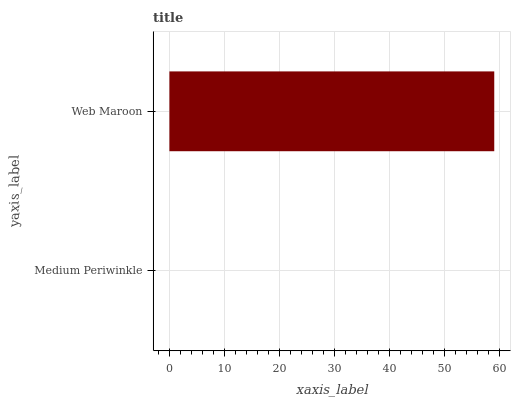Is Medium Periwinkle the minimum?
Answer yes or no. Yes. Is Web Maroon the maximum?
Answer yes or no. Yes. Is Web Maroon the minimum?
Answer yes or no. No. Is Web Maroon greater than Medium Periwinkle?
Answer yes or no. Yes. Is Medium Periwinkle less than Web Maroon?
Answer yes or no. Yes. Is Medium Periwinkle greater than Web Maroon?
Answer yes or no. No. Is Web Maroon less than Medium Periwinkle?
Answer yes or no. No. Is Web Maroon the high median?
Answer yes or no. Yes. Is Medium Periwinkle the low median?
Answer yes or no. Yes. Is Medium Periwinkle the high median?
Answer yes or no. No. Is Web Maroon the low median?
Answer yes or no. No. 